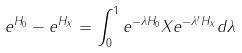Convert formula to latex. <formula><loc_0><loc_0><loc_500><loc_500>e ^ { H _ { 0 } } - e ^ { H _ { X } } = \int _ { 0 } ^ { 1 } e ^ { - \lambda H _ { 0 } } X e ^ { - \lambda ^ { \prime } H _ { X } } d \lambda</formula> 